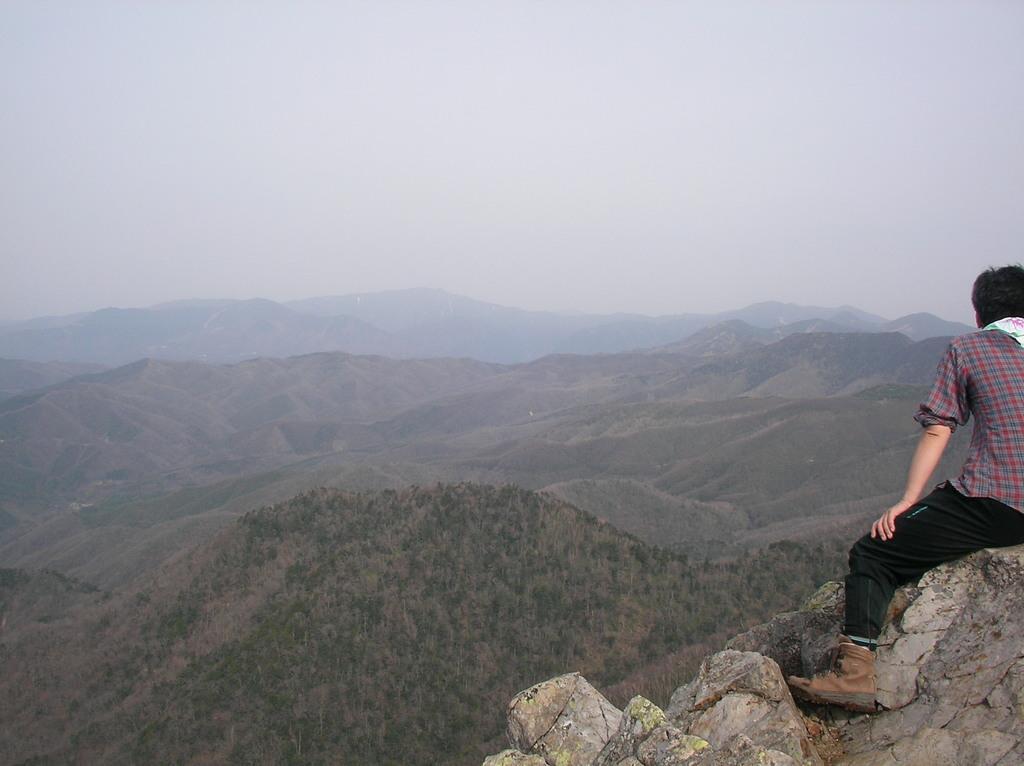Describe this image in one or two sentences. There is a person sitting on the stones in the foreground area of the image, there are mountains and the sky in the background. 